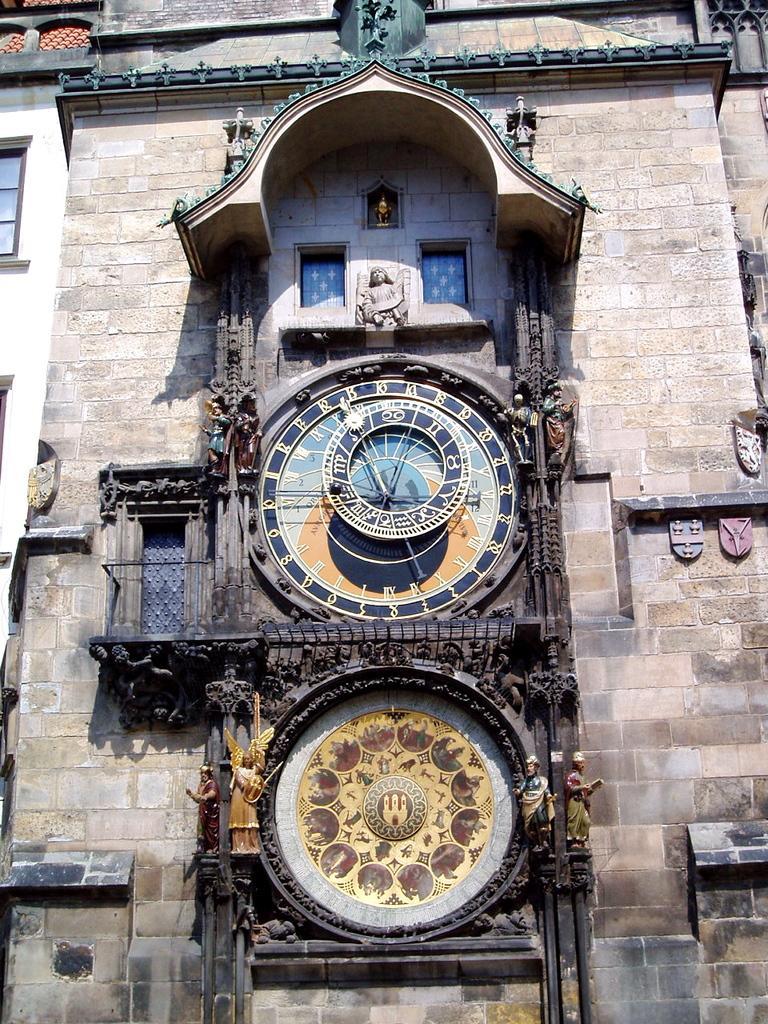In one or two sentences, can you explain what this image depicts? In the image there is a building with a clock in the middle and a emblem below it with statues on either side of it. 